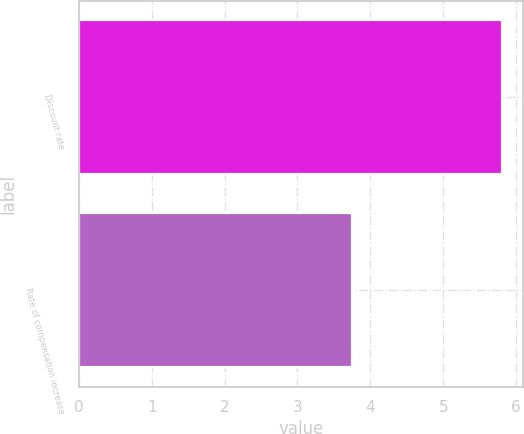Convert chart to OTSL. <chart><loc_0><loc_0><loc_500><loc_500><bar_chart><fcel>Discount rate<fcel>Rate of compensation increase<nl><fcel>5.8<fcel>3.75<nl></chart> 